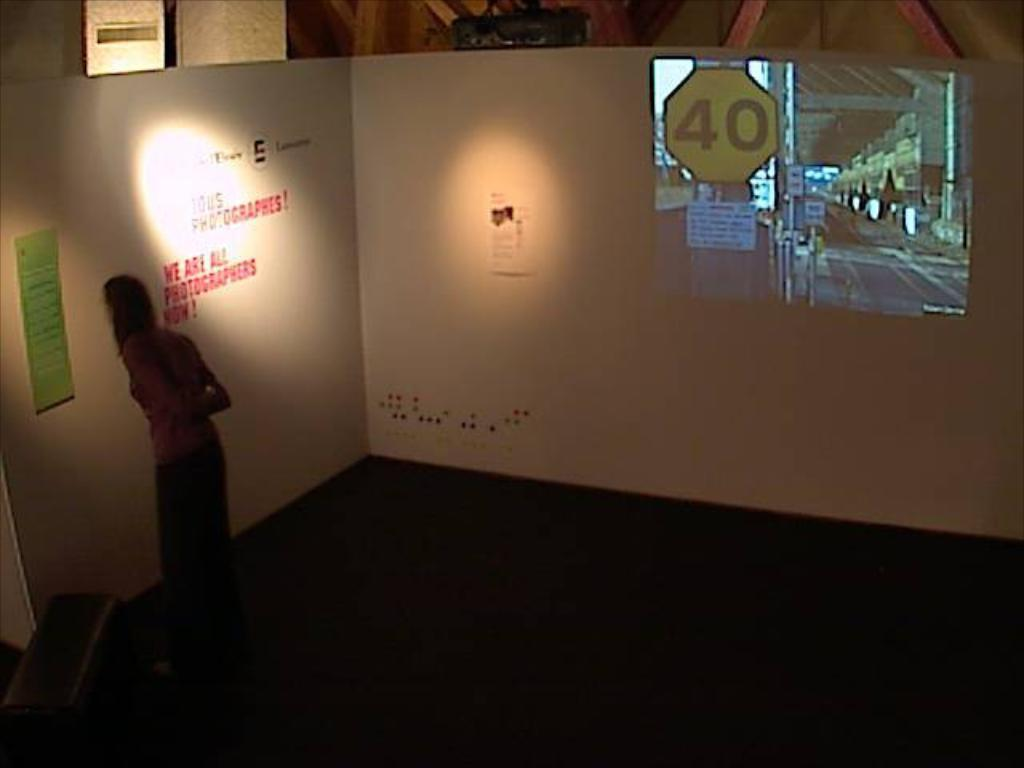What type of structure can be seen in the image? There is a wall in the image. What is hanging on the wall? There is a poster in the image. Who is present in the image? There is a woman in the image. What object can be used for personal grooming in the image? There is a mirror in the image. What type of pan is being used to burn the poster in the image? There is no pan or burning activity present in the image. 